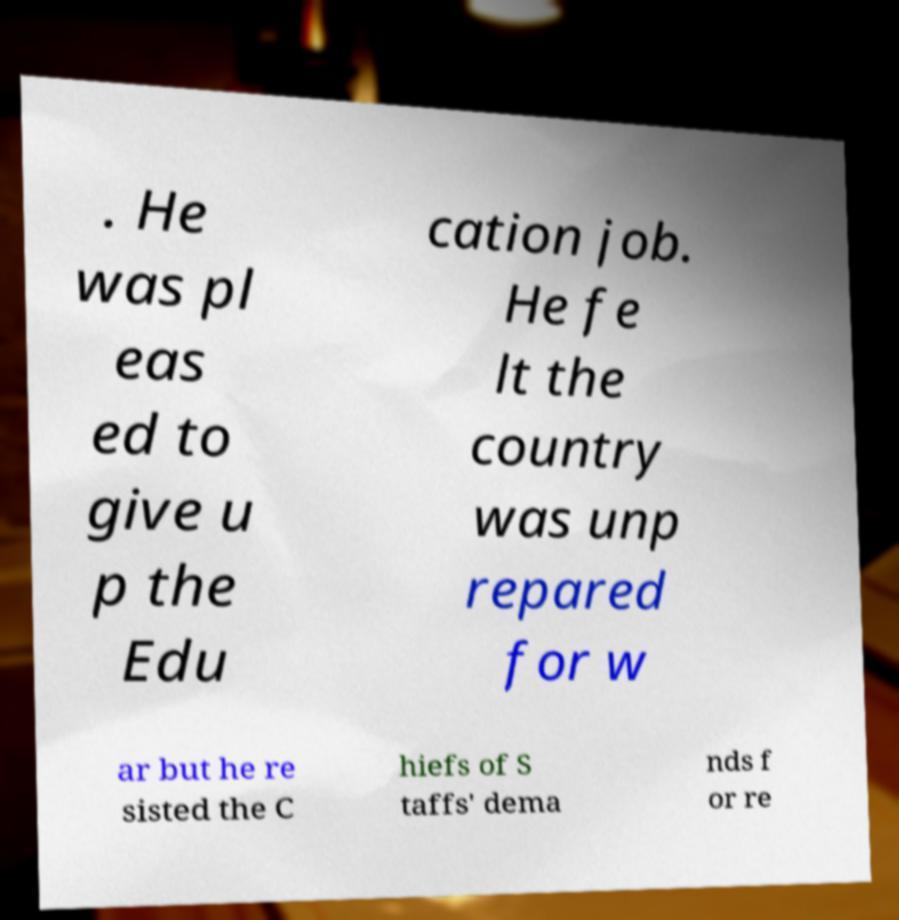For documentation purposes, I need the text within this image transcribed. Could you provide that? . He was pl eas ed to give u p the Edu cation job. He fe lt the country was unp repared for w ar but he re sisted the C hiefs of S taffs' dema nds f or re 